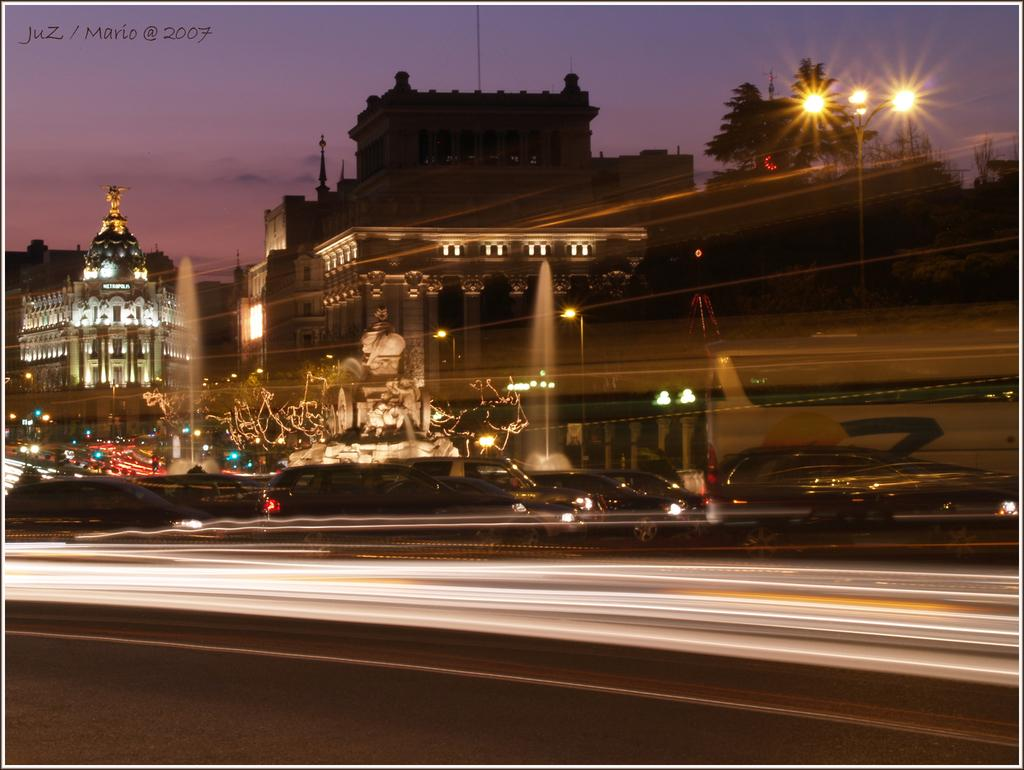What type of structures can be seen in the image? There are buildings in the image. What feature do the buildings have? The buildings have lights. What else can be seen in the image besides the buildings? There are poles, trees, a road, vehicles, a statue, and the sky visible in the image. What is the condition of the sky in the image? The sky is visible in the image, and there are clouds present. Is there any text visible in the image? Yes, there is some text on the top left side of the image. What type of border can be seen around the zebra in the image? There is no zebra present in the image, so there is no border around a zebra. 